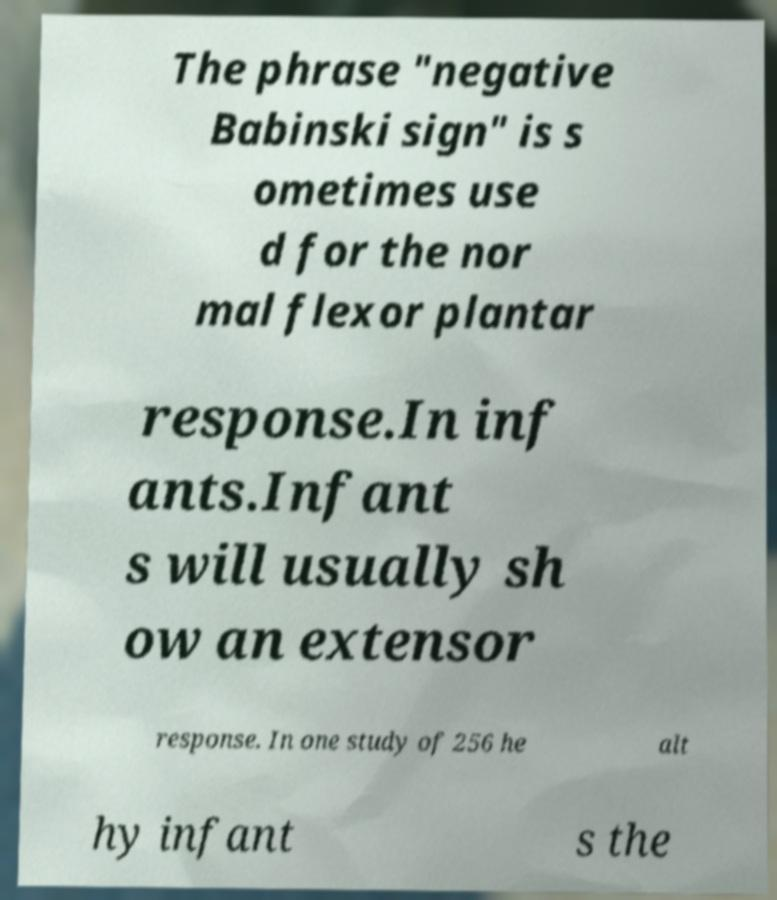Could you extract and type out the text from this image? The phrase "negative Babinski sign" is s ometimes use d for the nor mal flexor plantar response.In inf ants.Infant s will usually sh ow an extensor response. In one study of 256 he alt hy infant s the 